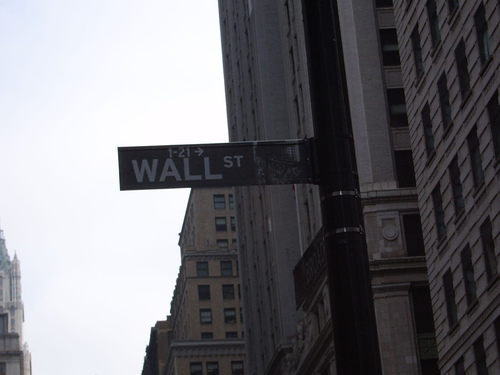<image>What is the green stuff on the other side of the window? It is ambiguous what the green stuff on the other side of the window is. It can be a sign, paint, or a street sign. What is the green stuff on the other side of the window? I am not sure what the green stuff on the other side of the window is. It can be a sign or paint. 